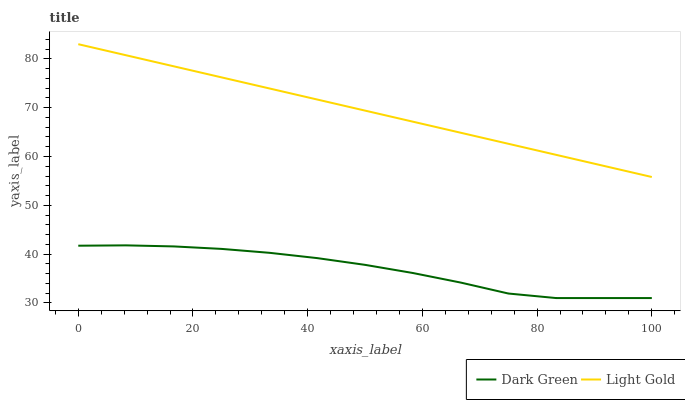Does Dark Green have the minimum area under the curve?
Answer yes or no. Yes. Does Light Gold have the maximum area under the curve?
Answer yes or no. Yes. Does Dark Green have the maximum area under the curve?
Answer yes or no. No. Is Light Gold the smoothest?
Answer yes or no. Yes. Is Dark Green the roughest?
Answer yes or no. Yes. Is Dark Green the smoothest?
Answer yes or no. No. Does Dark Green have the lowest value?
Answer yes or no. Yes. Does Light Gold have the highest value?
Answer yes or no. Yes. Does Dark Green have the highest value?
Answer yes or no. No. Is Dark Green less than Light Gold?
Answer yes or no. Yes. Is Light Gold greater than Dark Green?
Answer yes or no. Yes. Does Dark Green intersect Light Gold?
Answer yes or no. No. 